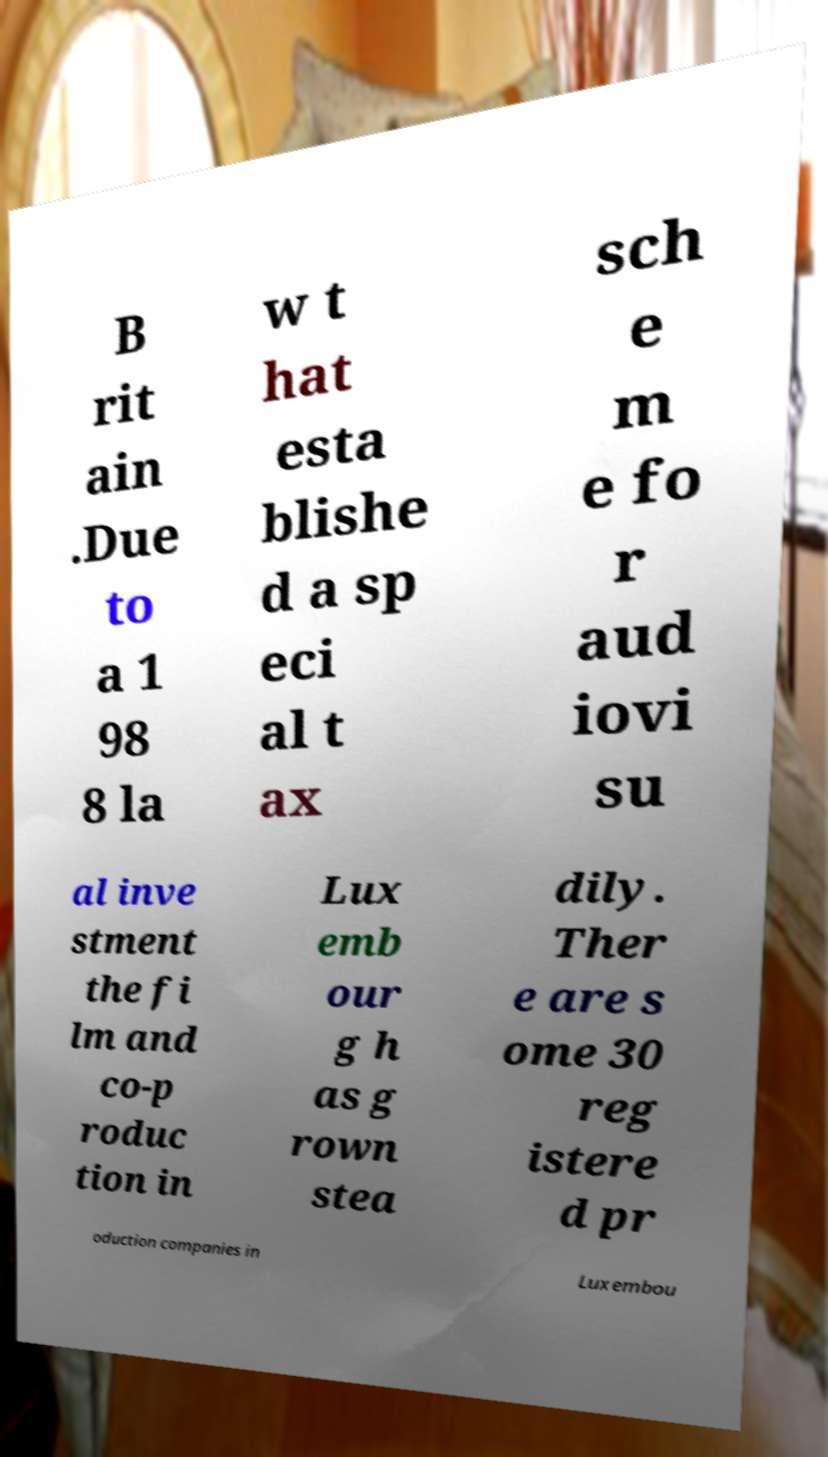Could you extract and type out the text from this image? B rit ain .Due to a 1 98 8 la w t hat esta blishe d a sp eci al t ax sch e m e fo r aud iovi su al inve stment the fi lm and co-p roduc tion in Lux emb our g h as g rown stea dily. Ther e are s ome 30 reg istere d pr oduction companies in Luxembou 